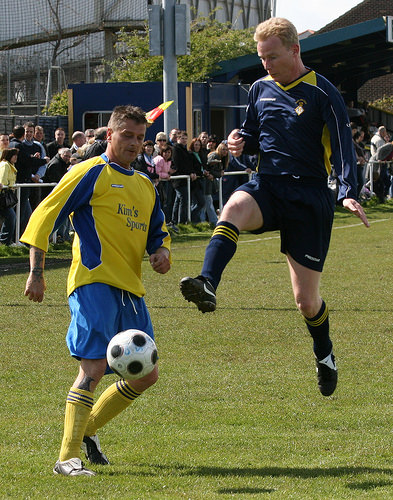<image>
Is there a ball in front of the player? Yes. The ball is positioned in front of the player, appearing closer to the camera viewpoint. Is the man in front of the ball? No. The man is not in front of the ball. The spatial positioning shows a different relationship between these objects. 